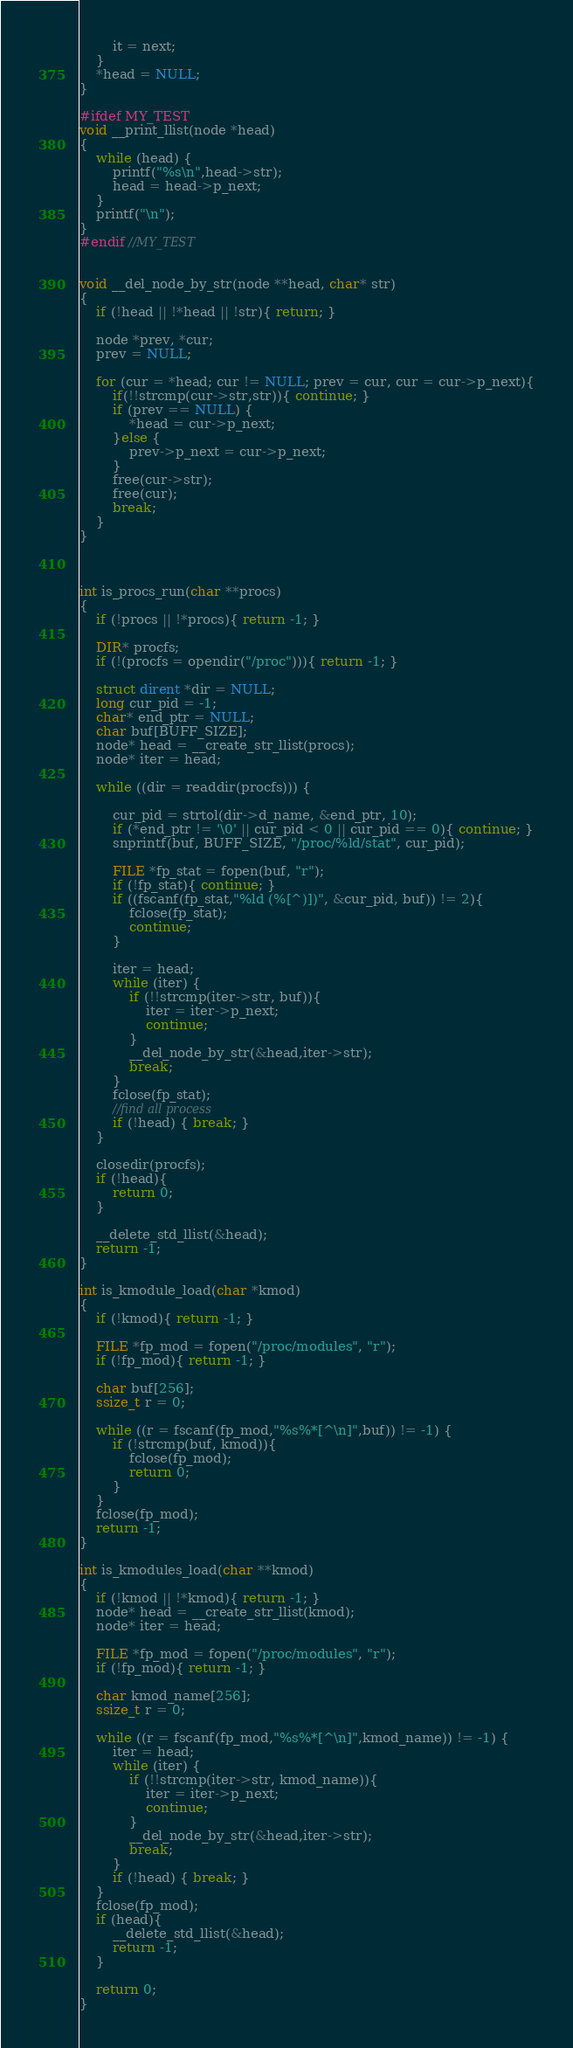Convert code to text. <code><loc_0><loc_0><loc_500><loc_500><_C_>        it = next;
    }
    *head = NULL;
}

#ifdef MY_TEST
void __print_llist(node *head)
{
    while (head) {
        printf("%s\n",head->str);
        head = head->p_next;
    }
    printf("\n");
}
#endif //MY_TEST


void __del_node_by_str(node **head, char* str)
{
    if (!head || !*head || !str){ return; }

    node *prev, *cur;
    prev = NULL;

    for (cur = *head; cur != NULL; prev = cur, cur = cur->p_next){
        if(!!strcmp(cur->str,str)){ continue; }
        if (prev == NULL) {
            *head = cur->p_next;
        }else {
            prev->p_next = cur->p_next;
        }
        free(cur->str);
        free(cur);
        break;
    }
}



int is_procs_run(char **procs)
{
    if (!procs || !*procs){ return -1; }

    DIR* procfs;
    if (!(procfs = opendir("/proc"))){ return -1; }

    struct dirent *dir = NULL;
    long cur_pid = -1;
    char* end_ptr = NULL;
    char buf[BUFF_SIZE];
    node* head = __create_str_llist(procs);
    node* iter = head;

    while ((dir = readdir(procfs))) {

        cur_pid = strtol(dir->d_name, &end_ptr, 10);
        if (*end_ptr != '\0' || cur_pid < 0 || cur_pid == 0){ continue; }
        snprintf(buf, BUFF_SIZE, "/proc/%ld/stat", cur_pid);

        FILE *fp_stat = fopen(buf, "r");
        if (!fp_stat){ continue; }
        if ((fscanf(fp_stat,"%ld (%[^)])", &cur_pid, buf)) != 2){
            fclose(fp_stat);
            continue;
        }

        iter = head;
        while (iter) {
            if (!!strcmp(iter->str, buf)){
                iter = iter->p_next;
                continue;
            }
            __del_node_by_str(&head,iter->str);
            break;
        }
        fclose(fp_stat);
        //find all process
        if (!head) { break; }
    }

    closedir(procfs);
    if (!head){
        return 0;
    }

    __delete_std_llist(&head);
    return -1;
}

int is_kmodule_load(char *kmod)
{
    if (!kmod){ return -1; }

    FILE *fp_mod = fopen("/proc/modules", "r");
    if (!fp_mod){ return -1; }

    char buf[256];
    ssize_t r = 0;

    while ((r = fscanf(fp_mod,"%s%*[^\n]",buf)) != -1) {
        if (!strcmp(buf, kmod)){
            fclose(fp_mod);
            return 0;
        }
    }
    fclose(fp_mod);
    return -1;
}

int is_kmodules_load(char **kmod)
{
    if (!kmod || !*kmod){ return -1; }
    node* head = __create_str_llist(kmod);
    node* iter = head;

    FILE *fp_mod = fopen("/proc/modules", "r");
    if (!fp_mod){ return -1; }

    char kmod_name[256];
    ssize_t r = 0;

    while ((r = fscanf(fp_mod,"%s%*[^\n]",kmod_name)) != -1) {
        iter = head;
        while (iter) {
            if (!!strcmp(iter->str, kmod_name)){
                iter = iter->p_next;
                continue;
            }
            __del_node_by_str(&head,iter->str);
            break;
        }
        if (!head) { break; }
    }
    fclose(fp_mod);
    if (head){
        __delete_std_llist(&head);
        return -1;
    }

    return 0;
}
</code> 